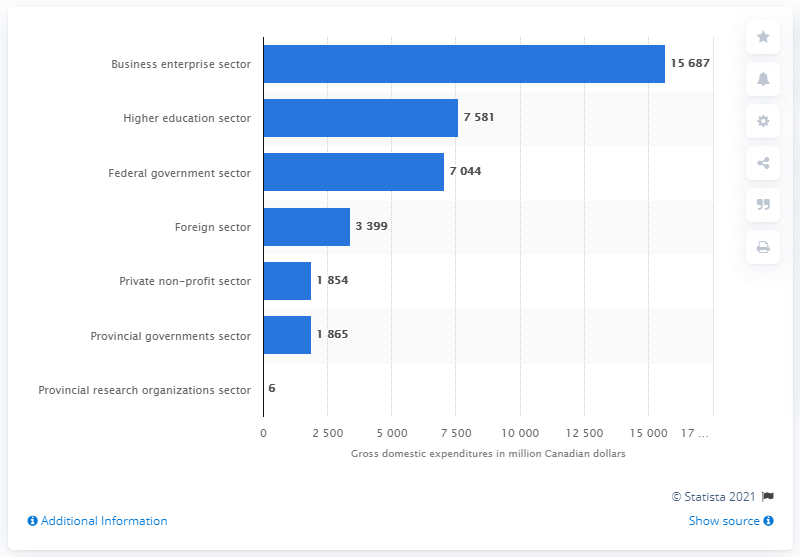Identify some key points in this picture. In 2020, the business enterprise sector in Canada received a total of CAD 15,687 in research and development (R&D) funding. In 2020, the amount of funding in the higher education sector in Canada was CAD 7,581 million. 